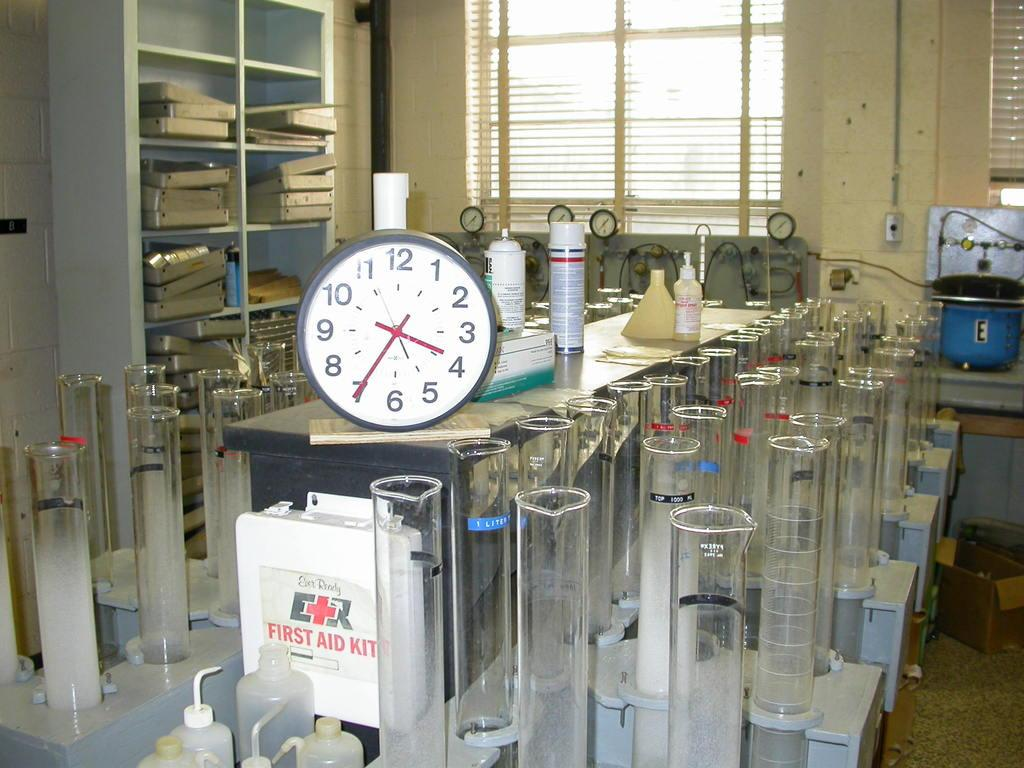<image>
Provide a brief description of the given image. Clock with the hands on the 4 and 7 inside of a science roomm. 